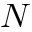<formula> <loc_0><loc_0><loc_500><loc_500>N</formula> 